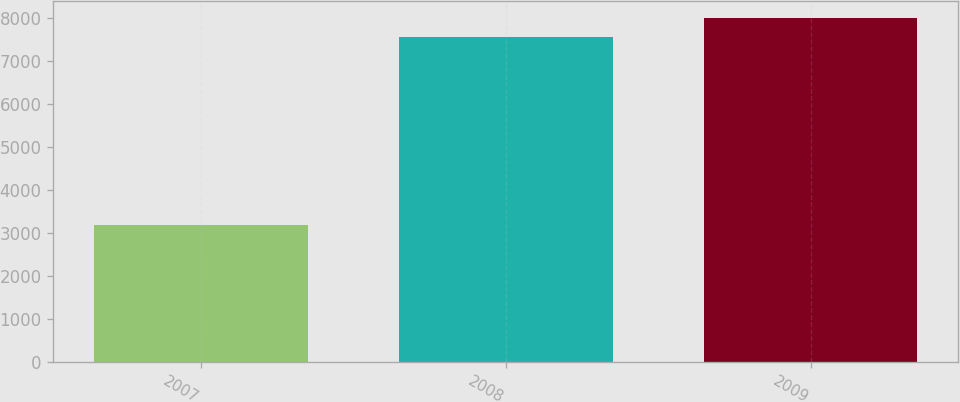Convert chart to OTSL. <chart><loc_0><loc_0><loc_500><loc_500><bar_chart><fcel>2007<fcel>2008<fcel>2009<nl><fcel>3206<fcel>7577<fcel>8014.1<nl></chart> 